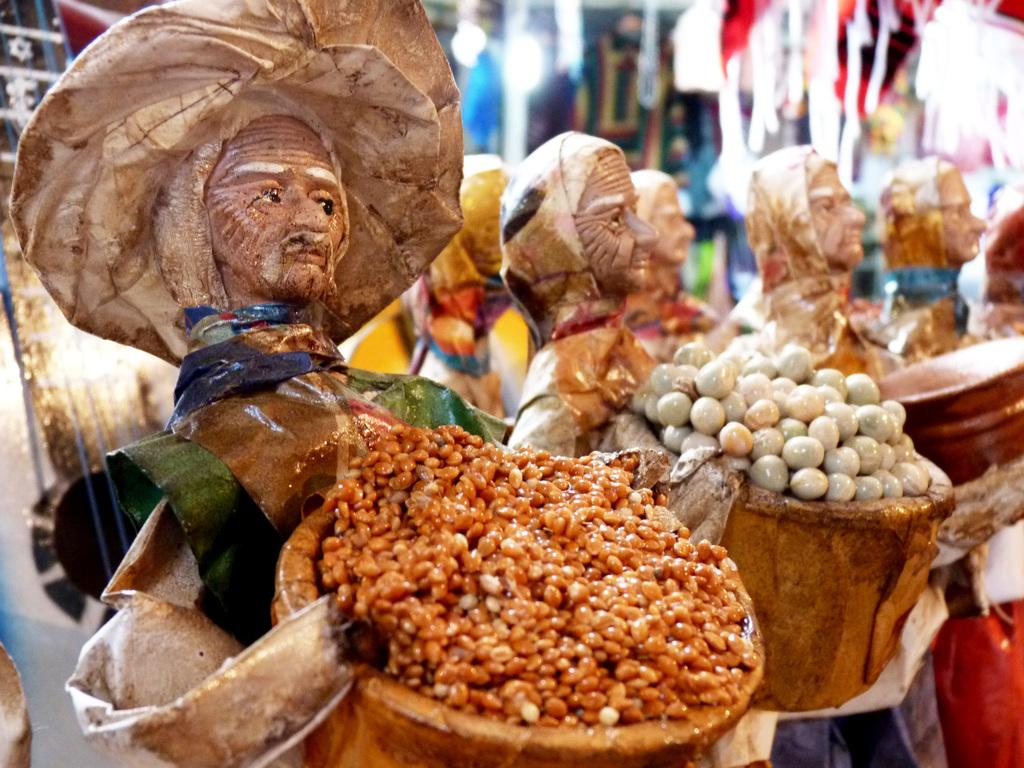What objects can be seen in the image? There are toys in the image. What are the toys doing with the basket? The toys are holding a basket. What is inside the basket? The basket contains food. How does the body of the toy expand when it picks up the basket? The toys in the image do not have bodies that can expand, and they are not shown picking up the basket. 